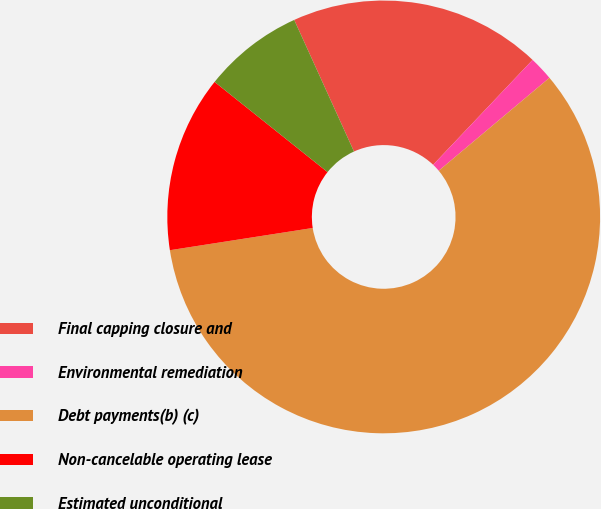<chart> <loc_0><loc_0><loc_500><loc_500><pie_chart><fcel>Final capping closure and<fcel>Environmental remediation<fcel>Debt payments(b) (c)<fcel>Non-cancelable operating lease<fcel>Estimated unconditional<nl><fcel>18.86%<fcel>1.81%<fcel>58.65%<fcel>13.18%<fcel>7.49%<nl></chart> 